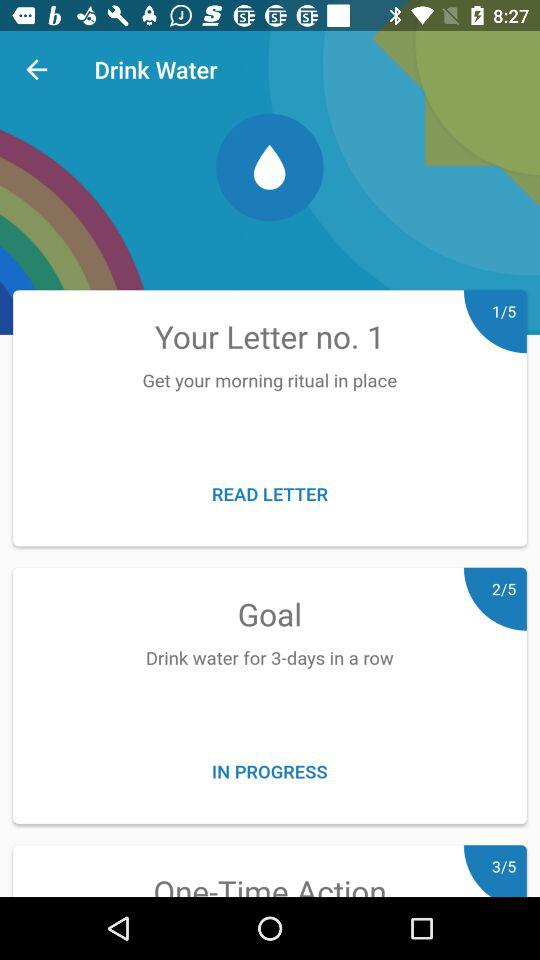How many days in total are there in "Goal"? There are 5 days in total. 